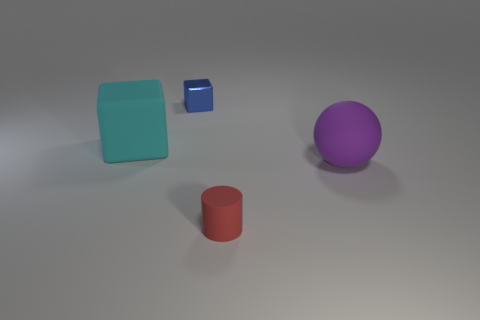Subtract all brown balls. Subtract all purple cylinders. How many balls are left? 1 Subtract all gray spheres. How many green blocks are left? 0 Add 2 large grays. How many tiny reds exist? 0 Subtract all large matte objects. Subtract all small blue metal things. How many objects are left? 1 Add 4 large cyan cubes. How many large cyan cubes are left? 5 Add 2 purple rubber balls. How many purple rubber balls exist? 3 Add 1 big objects. How many objects exist? 5 Subtract all blue blocks. How many blocks are left? 1 Subtract 0 yellow balls. How many objects are left? 4 Subtract all spheres. How many objects are left? 3 